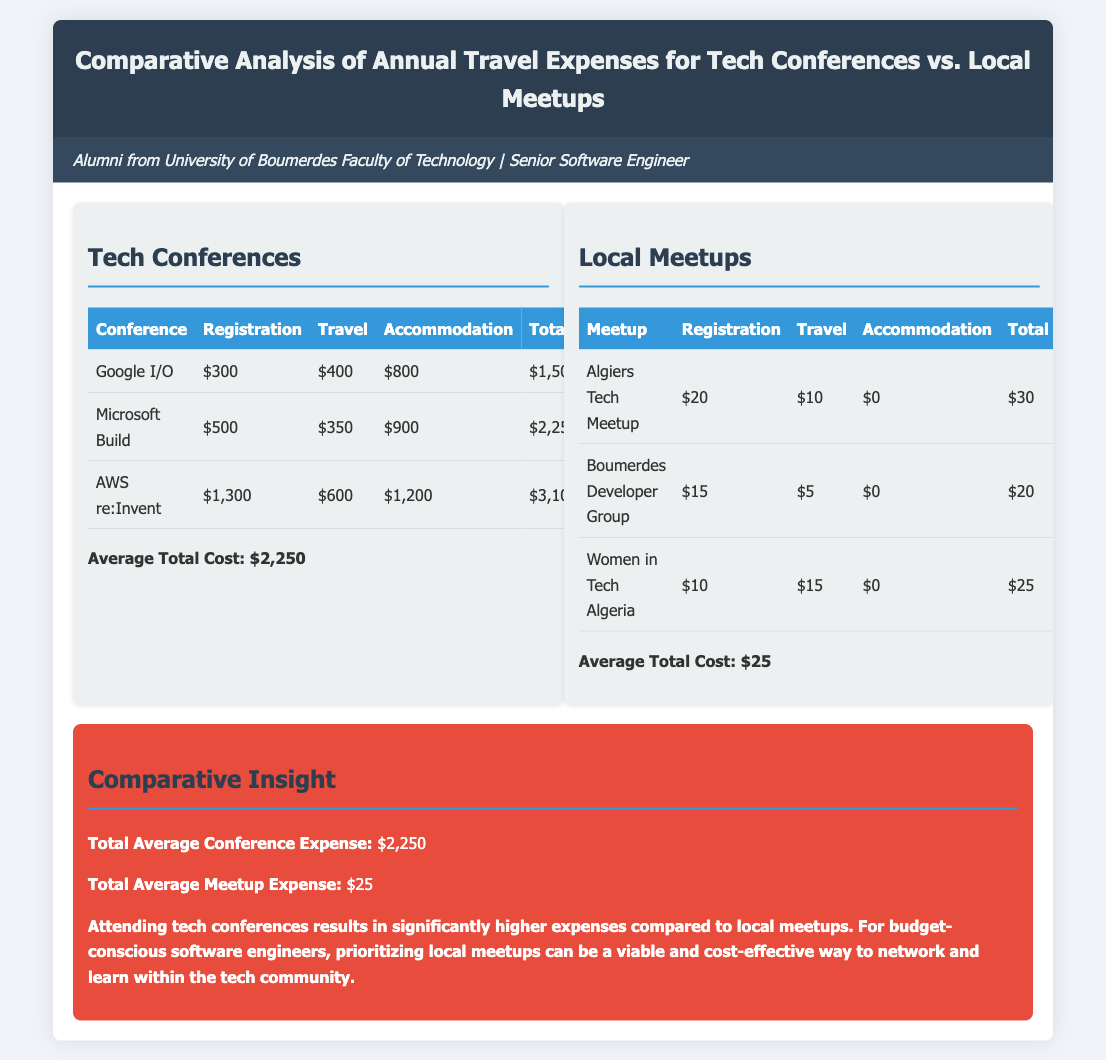What is the total cost of attending Google I/O? The total cost for attending Google I/O includes registration, travel, and accommodation, which sums up to $1,500.
Answer: $1,500 What is the average total cost for tech conferences? The average total cost for tech conferences is calculated by averaging the total costs of the individual conferences listed, which is $2,250.
Answer: $2,250 How much does the Boumerdes Developer Group charge for registration? The registration fee for the Boumerdes Developer Group is listed as $15.
Answer: $15 What is the total average meetup expense? The total average meetup expense is derived from the average of the total costs of the local meetups, which is $25.
Answer: $25 Which conference has the highest accommodation cost? The conference with the highest accommodation cost is AWS re:Invent, with a cost of $1,200.
Answer: AWS re:Invent How much more expensive is attending AWS re:Invent compared to the Algiers Tech Meetup? The total expense for AWS re:Invent is $3,100 while for Algiers Tech Meetup it is $30, making the difference $3,070.
Answer: $3,070 What can be concluded about the expenses for tech conferences versus local meetups? The document concludes that attending tech conferences results in significantly higher expenses compared to local meetups.
Answer: Higher expenses How many local meetups are listed in the analysis? There are three local meetups mentioned in the analysis: Algiers Tech Meetup, Boumerdes Developer Group, and Women in Tech Algeria.
Answer: Three What is the total travel cost for attending Microsoft Build? The travel cost specifically for attending Microsoft Build is noted as $350.
Answer: $350 What is a cost-effective way for budget-conscious software engineers to network? The document suggests prioritizing local meetups as a viable and cost-effective way.
Answer: Local meetups 